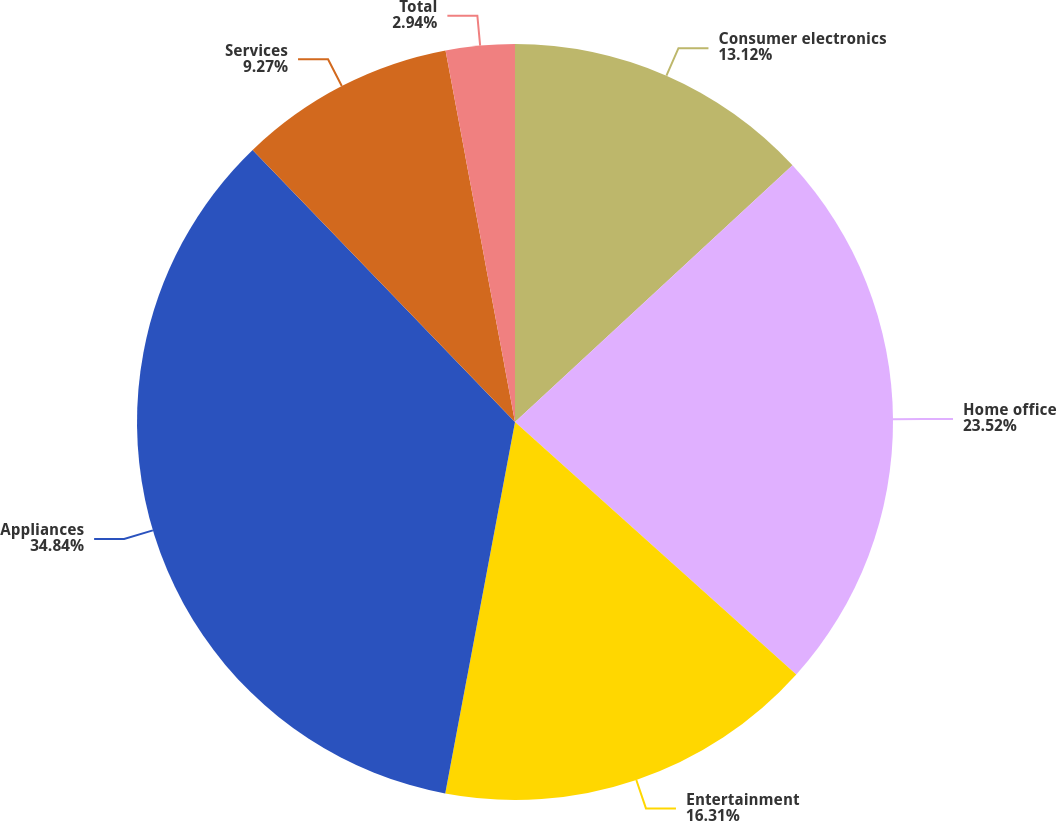<chart> <loc_0><loc_0><loc_500><loc_500><pie_chart><fcel>Consumer electronics<fcel>Home office<fcel>Entertainment<fcel>Appliances<fcel>Services<fcel>Total<nl><fcel>13.12%<fcel>23.52%<fcel>16.31%<fcel>34.83%<fcel>9.27%<fcel>2.94%<nl></chart> 